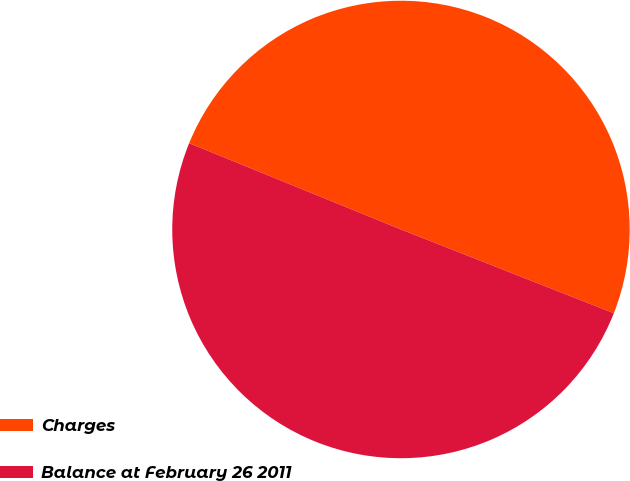Convert chart to OTSL. <chart><loc_0><loc_0><loc_500><loc_500><pie_chart><fcel>Charges<fcel>Balance at February 26 2011<nl><fcel>49.81%<fcel>50.19%<nl></chart> 